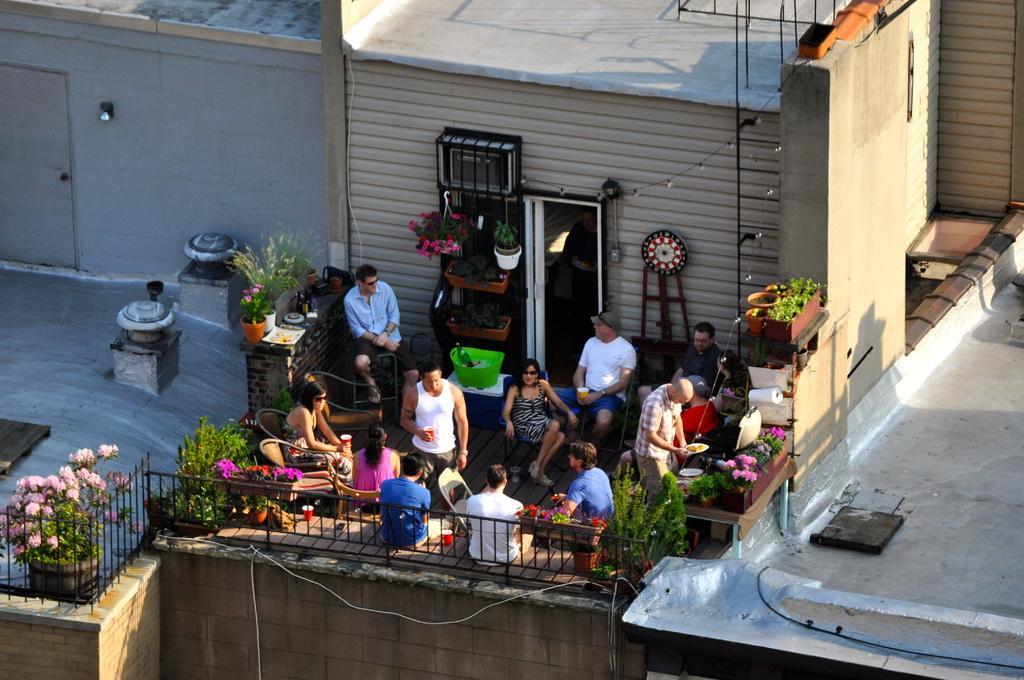In one or two sentences, can you explain what this image depicts? In this picture there are group of persons sitting where two among them are standing and there are few plants around them and there is a fence in the left corner and there are some other objects in the background. 